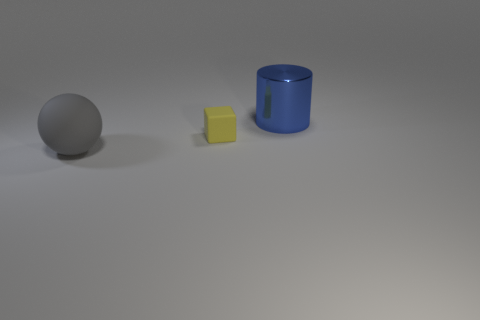Add 1 small gray matte spheres. How many objects exist? 4 Subtract all cylinders. How many objects are left? 2 Subtract all gray blocks. Subtract all green cylinders. How many blocks are left? 1 Subtract 1 blue cylinders. How many objects are left? 2 Subtract all large spheres. Subtract all large blue metal objects. How many objects are left? 1 Add 2 blue metal objects. How many blue metal objects are left? 3 Add 1 big cyan cylinders. How many big cyan cylinders exist? 1 